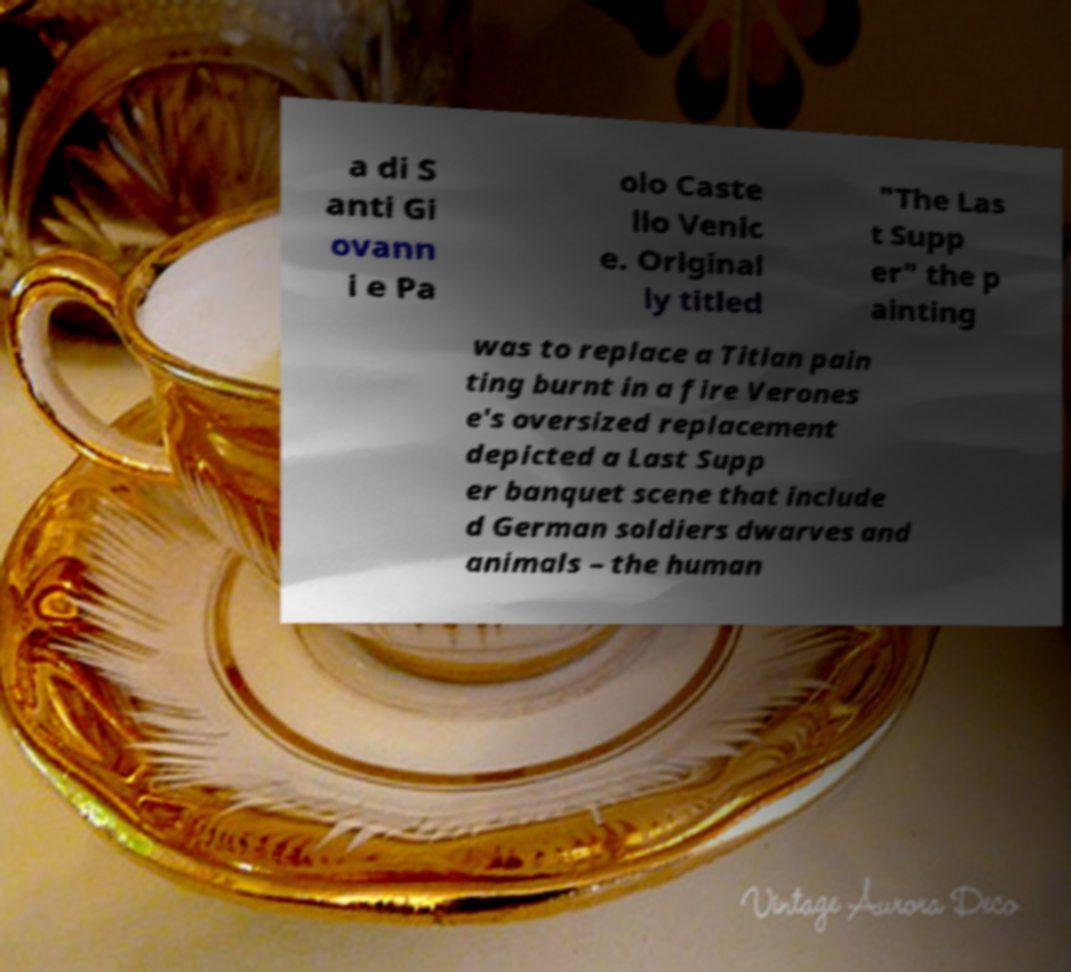Please read and relay the text visible in this image. What does it say? a di S anti Gi ovann i e Pa olo Caste llo Venic e. Original ly titled "The Las t Supp er" the p ainting was to replace a Titian pain ting burnt in a fire Verones e's oversized replacement depicted a Last Supp er banquet scene that include d German soldiers dwarves and animals – the human 